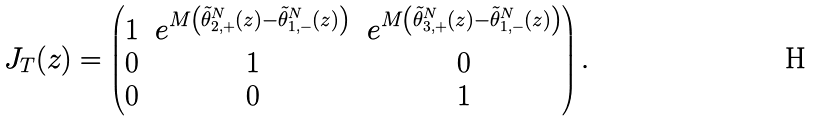Convert formula to latex. <formula><loc_0><loc_0><loc_500><loc_500>J _ { T } ( z ) & = \begin{pmatrix} 1 & e ^ { M \left ( \tilde { \theta } _ { 2 , + } ^ { N } ( z ) - \tilde { \theta } _ { 1 , - } ^ { N } ( z ) \right ) } & e ^ { M \left ( \tilde { \theta } _ { 3 , + } ^ { N } ( z ) - \tilde { \theta } _ { 1 , - } ^ { N } ( z ) \right ) } \\ 0 & 1 & 0 \\ 0 & 0 & 1 \end{pmatrix} .</formula> 